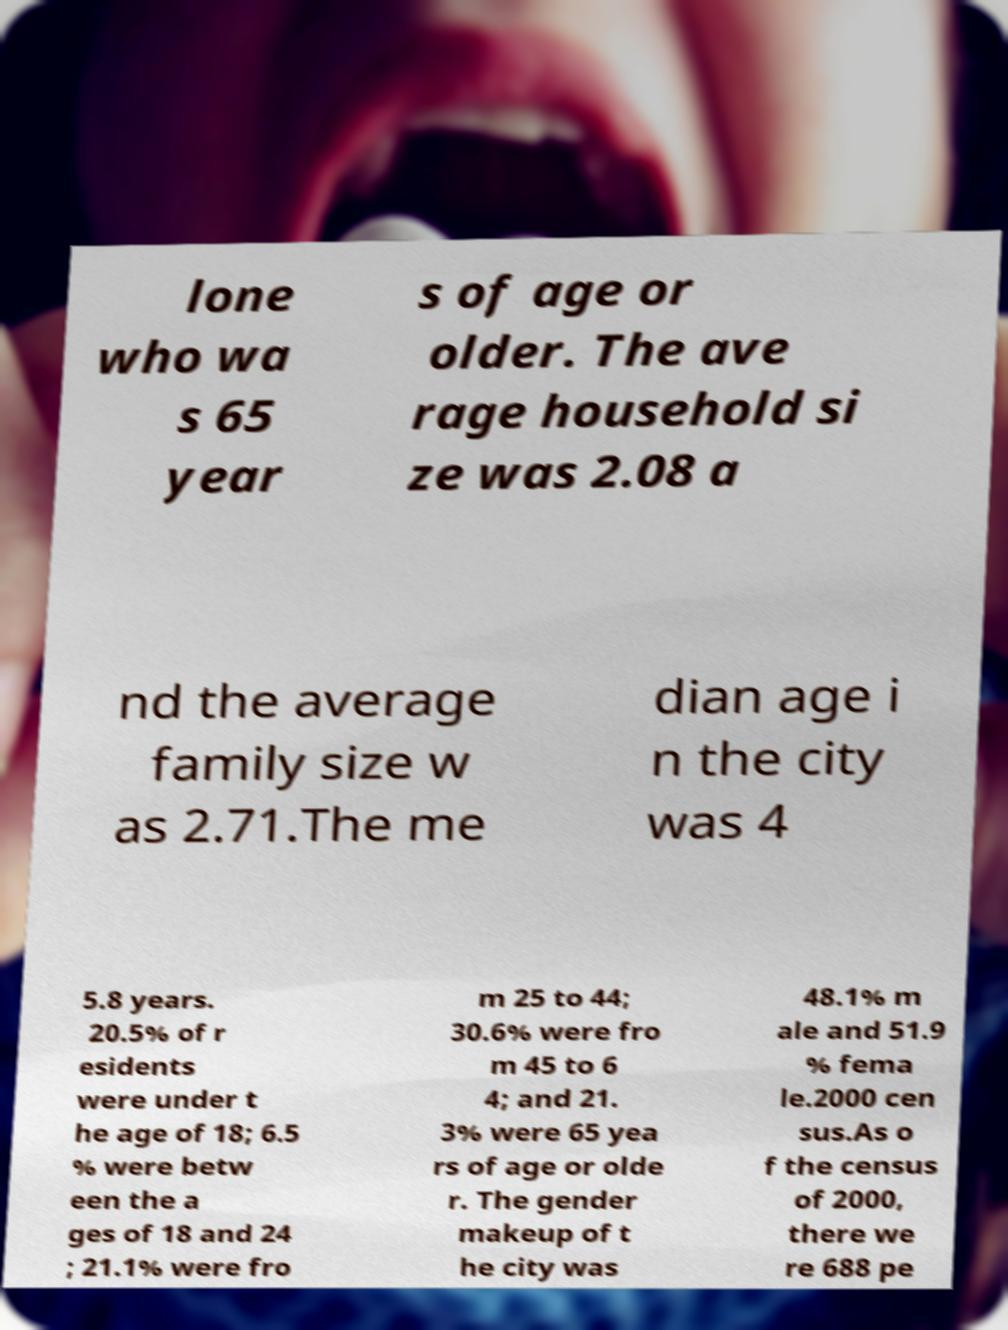Could you extract and type out the text from this image? lone who wa s 65 year s of age or older. The ave rage household si ze was 2.08 a nd the average family size w as 2.71.The me dian age i n the city was 4 5.8 years. 20.5% of r esidents were under t he age of 18; 6.5 % were betw een the a ges of 18 and 24 ; 21.1% were fro m 25 to 44; 30.6% were fro m 45 to 6 4; and 21. 3% were 65 yea rs of age or olde r. The gender makeup of t he city was 48.1% m ale and 51.9 % fema le.2000 cen sus.As o f the census of 2000, there we re 688 pe 